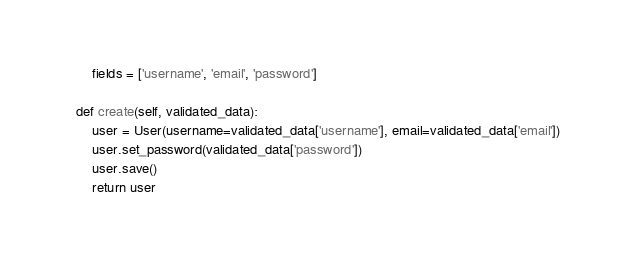<code> <loc_0><loc_0><loc_500><loc_500><_Python_>        fields = ['username', 'email', 'password']

    def create(self, validated_data):
        user = User(username=validated_data['username'], email=validated_data['email'])
        user.set_password(validated_data['password'])
        user.save()
        return user</code> 